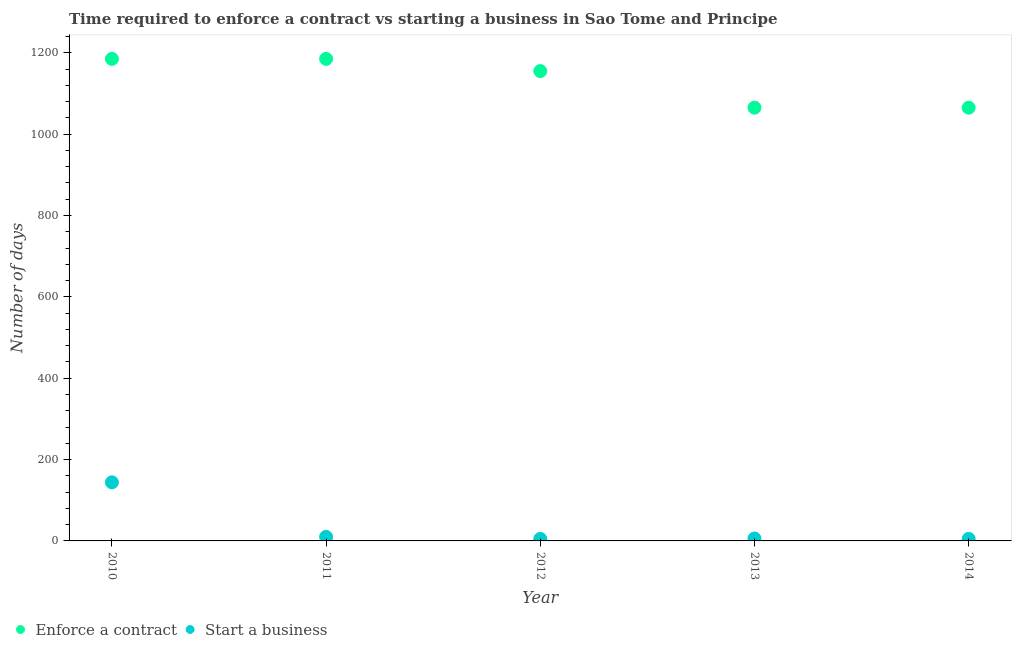What is the number of days to start a business in 2014?
Your response must be concise. 5. Across all years, what is the maximum number of days to start a business?
Provide a succinct answer. 144. Across all years, what is the minimum number of days to start a business?
Provide a succinct answer. 5. What is the total number of days to start a business in the graph?
Ensure brevity in your answer.  170. What is the difference between the number of days to start a business in 2012 and that in 2013?
Your answer should be compact. -1. What is the difference between the number of days to start a business in 2011 and the number of days to enforece a contract in 2010?
Offer a very short reply. -1175. What is the average number of days to enforece a contract per year?
Ensure brevity in your answer.  1131. In the year 2012, what is the difference between the number of days to start a business and number of days to enforece a contract?
Make the answer very short. -1150. What is the ratio of the number of days to enforece a contract in 2012 to that in 2013?
Your answer should be very brief. 1.08. What is the difference between the highest and the second highest number of days to enforece a contract?
Offer a very short reply. 0. What is the difference between the highest and the lowest number of days to enforece a contract?
Make the answer very short. 120. Does the number of days to start a business monotonically increase over the years?
Provide a succinct answer. No. Where does the legend appear in the graph?
Keep it short and to the point. Bottom left. How are the legend labels stacked?
Make the answer very short. Horizontal. What is the title of the graph?
Your response must be concise. Time required to enforce a contract vs starting a business in Sao Tome and Principe. Does "Arms exports" appear as one of the legend labels in the graph?
Your response must be concise. No. What is the label or title of the X-axis?
Your answer should be compact. Year. What is the label or title of the Y-axis?
Keep it short and to the point. Number of days. What is the Number of days of Enforce a contract in 2010?
Provide a short and direct response. 1185. What is the Number of days in Start a business in 2010?
Offer a terse response. 144. What is the Number of days of Enforce a contract in 2011?
Provide a succinct answer. 1185. What is the Number of days in Enforce a contract in 2012?
Make the answer very short. 1155. What is the Number of days of Enforce a contract in 2013?
Make the answer very short. 1065. What is the Number of days of Start a business in 2013?
Offer a terse response. 6. What is the Number of days in Enforce a contract in 2014?
Offer a very short reply. 1065. What is the Number of days in Start a business in 2014?
Make the answer very short. 5. Across all years, what is the maximum Number of days of Enforce a contract?
Your answer should be compact. 1185. Across all years, what is the maximum Number of days in Start a business?
Offer a very short reply. 144. Across all years, what is the minimum Number of days of Enforce a contract?
Keep it short and to the point. 1065. What is the total Number of days of Enforce a contract in the graph?
Ensure brevity in your answer.  5655. What is the total Number of days in Start a business in the graph?
Provide a succinct answer. 170. What is the difference between the Number of days of Start a business in 2010 and that in 2011?
Your response must be concise. 134. What is the difference between the Number of days in Enforce a contract in 2010 and that in 2012?
Ensure brevity in your answer.  30. What is the difference between the Number of days in Start a business in 2010 and that in 2012?
Offer a very short reply. 139. What is the difference between the Number of days of Enforce a contract in 2010 and that in 2013?
Your response must be concise. 120. What is the difference between the Number of days in Start a business in 2010 and that in 2013?
Provide a short and direct response. 138. What is the difference between the Number of days in Enforce a contract in 2010 and that in 2014?
Your answer should be compact. 120. What is the difference between the Number of days in Start a business in 2010 and that in 2014?
Your answer should be very brief. 139. What is the difference between the Number of days in Enforce a contract in 2011 and that in 2012?
Provide a succinct answer. 30. What is the difference between the Number of days of Start a business in 2011 and that in 2012?
Your response must be concise. 5. What is the difference between the Number of days in Enforce a contract in 2011 and that in 2013?
Your answer should be compact. 120. What is the difference between the Number of days in Enforce a contract in 2011 and that in 2014?
Offer a very short reply. 120. What is the difference between the Number of days in Start a business in 2011 and that in 2014?
Provide a succinct answer. 5. What is the difference between the Number of days of Start a business in 2012 and that in 2013?
Your answer should be very brief. -1. What is the difference between the Number of days of Enforce a contract in 2012 and that in 2014?
Offer a terse response. 90. What is the difference between the Number of days of Start a business in 2013 and that in 2014?
Your answer should be compact. 1. What is the difference between the Number of days in Enforce a contract in 2010 and the Number of days in Start a business in 2011?
Make the answer very short. 1175. What is the difference between the Number of days of Enforce a contract in 2010 and the Number of days of Start a business in 2012?
Your response must be concise. 1180. What is the difference between the Number of days in Enforce a contract in 2010 and the Number of days in Start a business in 2013?
Give a very brief answer. 1179. What is the difference between the Number of days in Enforce a contract in 2010 and the Number of days in Start a business in 2014?
Ensure brevity in your answer.  1180. What is the difference between the Number of days in Enforce a contract in 2011 and the Number of days in Start a business in 2012?
Offer a very short reply. 1180. What is the difference between the Number of days of Enforce a contract in 2011 and the Number of days of Start a business in 2013?
Offer a terse response. 1179. What is the difference between the Number of days in Enforce a contract in 2011 and the Number of days in Start a business in 2014?
Give a very brief answer. 1180. What is the difference between the Number of days in Enforce a contract in 2012 and the Number of days in Start a business in 2013?
Make the answer very short. 1149. What is the difference between the Number of days of Enforce a contract in 2012 and the Number of days of Start a business in 2014?
Provide a short and direct response. 1150. What is the difference between the Number of days in Enforce a contract in 2013 and the Number of days in Start a business in 2014?
Make the answer very short. 1060. What is the average Number of days of Enforce a contract per year?
Offer a very short reply. 1131. In the year 2010, what is the difference between the Number of days of Enforce a contract and Number of days of Start a business?
Give a very brief answer. 1041. In the year 2011, what is the difference between the Number of days in Enforce a contract and Number of days in Start a business?
Provide a succinct answer. 1175. In the year 2012, what is the difference between the Number of days in Enforce a contract and Number of days in Start a business?
Your answer should be compact. 1150. In the year 2013, what is the difference between the Number of days in Enforce a contract and Number of days in Start a business?
Offer a very short reply. 1059. In the year 2014, what is the difference between the Number of days in Enforce a contract and Number of days in Start a business?
Keep it short and to the point. 1060. What is the ratio of the Number of days of Enforce a contract in 2010 to that in 2011?
Provide a short and direct response. 1. What is the ratio of the Number of days in Start a business in 2010 to that in 2011?
Your answer should be compact. 14.4. What is the ratio of the Number of days of Start a business in 2010 to that in 2012?
Provide a short and direct response. 28.8. What is the ratio of the Number of days in Enforce a contract in 2010 to that in 2013?
Keep it short and to the point. 1.11. What is the ratio of the Number of days in Start a business in 2010 to that in 2013?
Provide a succinct answer. 24. What is the ratio of the Number of days in Enforce a contract in 2010 to that in 2014?
Offer a very short reply. 1.11. What is the ratio of the Number of days in Start a business in 2010 to that in 2014?
Your response must be concise. 28.8. What is the ratio of the Number of days in Start a business in 2011 to that in 2012?
Offer a terse response. 2. What is the ratio of the Number of days of Enforce a contract in 2011 to that in 2013?
Your answer should be compact. 1.11. What is the ratio of the Number of days of Enforce a contract in 2011 to that in 2014?
Give a very brief answer. 1.11. What is the ratio of the Number of days of Start a business in 2011 to that in 2014?
Make the answer very short. 2. What is the ratio of the Number of days of Enforce a contract in 2012 to that in 2013?
Your answer should be compact. 1.08. What is the ratio of the Number of days in Enforce a contract in 2012 to that in 2014?
Keep it short and to the point. 1.08. What is the ratio of the Number of days of Start a business in 2012 to that in 2014?
Offer a very short reply. 1. What is the difference between the highest and the second highest Number of days in Enforce a contract?
Make the answer very short. 0. What is the difference between the highest and the second highest Number of days of Start a business?
Offer a very short reply. 134. What is the difference between the highest and the lowest Number of days in Enforce a contract?
Your answer should be very brief. 120. What is the difference between the highest and the lowest Number of days of Start a business?
Ensure brevity in your answer.  139. 